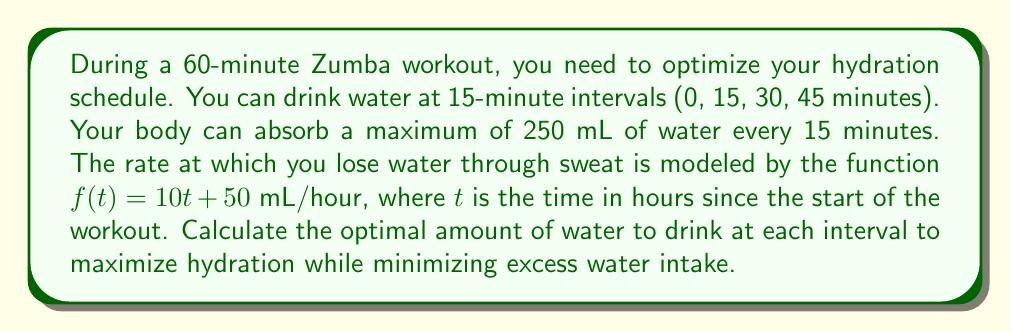Give your solution to this math problem. Let's approach this step-by-step:

1) First, we need to calculate the total water loss over the 60-minute workout:
   
   $$\int_0^1 (10t + 50) dt = [5t^2 + 50t]_0^1 = 55$$ mL

2) Now, we need to distribute this 55 mL loss over the four 15-minute intervals:
   
   For each interval: $55 \div 4 = 13.75$ mL

3) However, we can only drink water at discrete 15-minute intervals, and we want to stay ahead of dehydration. So, we should round up to the nearest mL:
   
   14 mL per 15-minute interval

4) But remember, we can absorb a maximum of 250 mL every 15 minutes. 14 mL is well below this limit, so it's feasible.

5) To optimize the hydration schedule:
   - At 0 minutes: Drink 14 mL to prepare for the first interval
   - At 15 minutes: Drink 14 mL to replenish the first interval and prepare for the second
   - At 30 minutes: Drink 14 mL to replenish the second interval and prepare for the third
   - At 45 minutes: Drink 14 mL to replenish the third interval and prepare for the final interval

6) The final 14 mL lost in the last interval will be replenished after the workout.

This schedule ensures you're always slightly ahead of your water loss, maximizing hydration while minimizing excess water intake.
Answer: The optimal hydration schedule is to drink 14 mL of water at 0, 15, 30, and 45 minutes into the Zumba workout. 